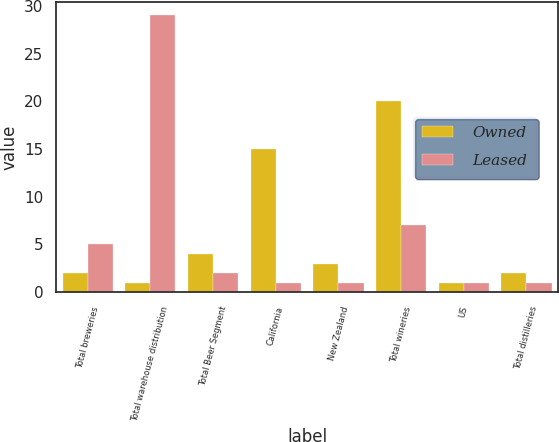<chart> <loc_0><loc_0><loc_500><loc_500><stacked_bar_chart><ecel><fcel>Total breweries<fcel>Total warehouse distribution<fcel>Total Beer Segment<fcel>California<fcel>New Zealand<fcel>Total wineries<fcel>US<fcel>Total distilleries<nl><fcel>Owned<fcel>2<fcel>1<fcel>4<fcel>15<fcel>3<fcel>20<fcel>1<fcel>2<nl><fcel>Leased<fcel>5<fcel>29<fcel>2<fcel>1<fcel>1<fcel>7<fcel>1<fcel>1<nl></chart> 